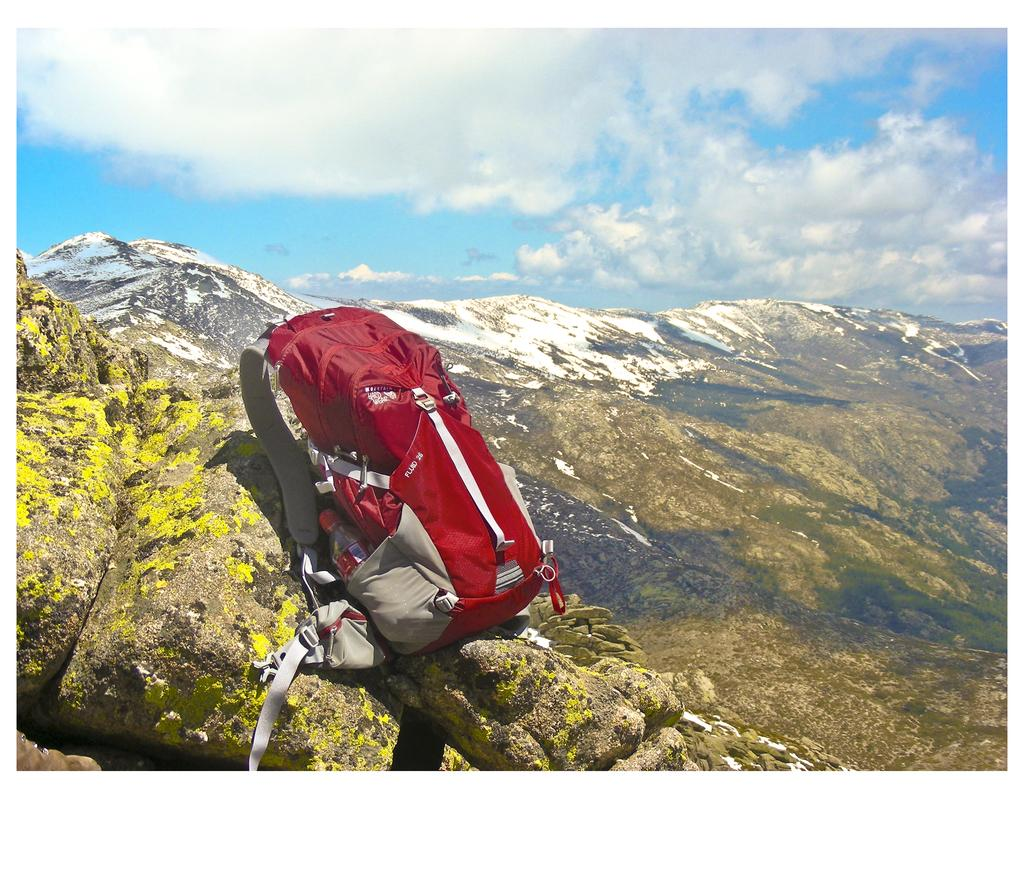What is the color of the bag that is visible in the image? There is a red color bag in the image. What other item with a strap can be seen in the image? There is a bottle with a strap in the image. Where are the bag and bottle located in the image? The bag and bottle are on a rock in the image. What is visible in the background of the image? There is sky, clouds, and a mountain visible in the background of the image. What type of comb can be seen in the image? There is no comb present in the image. What color is the color in the image? The question is unclear and seems to contain an error. The image does not contain a color, but rather a red color bag. 